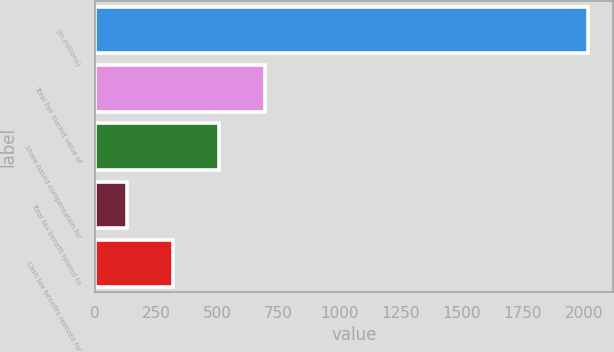<chart> <loc_0><loc_0><loc_500><loc_500><bar_chart><fcel>(In millions)<fcel>Total fair market value of<fcel>Share-based compensation for<fcel>Total tax benefit related to<fcel>Cash tax benefits realized for<nl><fcel>2017<fcel>696.1<fcel>507.4<fcel>130<fcel>318.7<nl></chart> 